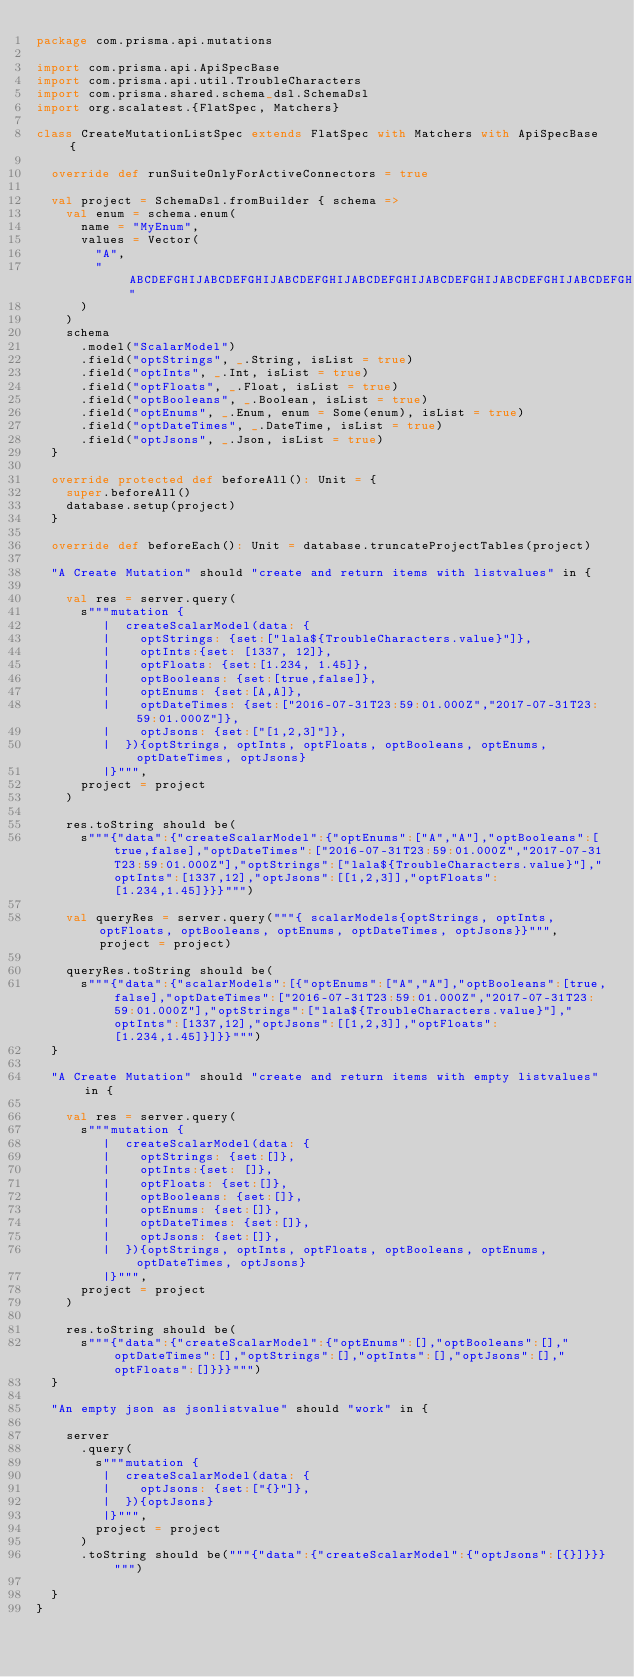Convert code to text. <code><loc_0><loc_0><loc_500><loc_500><_Scala_>package com.prisma.api.mutations

import com.prisma.api.ApiSpecBase
import com.prisma.api.util.TroubleCharacters
import com.prisma.shared.schema_dsl.SchemaDsl
import org.scalatest.{FlatSpec, Matchers}

class CreateMutationListSpec extends FlatSpec with Matchers with ApiSpecBase {

  override def runSuiteOnlyForActiveConnectors = true

  val project = SchemaDsl.fromBuilder { schema =>
    val enum = schema.enum(
      name = "MyEnum",
      values = Vector(
        "A",
        "ABCDEFGHIJABCDEFGHIJABCDEFGHIJABCDEFGHIJABCDEFGHIJABCDEFGHIJABCDEFGHIJABCDEFGHIJABCDEFGHIJABCDEFGHIJABCDEFGHIJABCDEFGHIJABCDEFGHIJABCDEFGHIJABCDEFGHIJABCDEFGHIJABCDEFGHIJABCDEFGHIJABCDEFGHIJABCDEFGHIJ"
      )
    )
    schema
      .model("ScalarModel")
      .field("optStrings", _.String, isList = true)
      .field("optInts", _.Int, isList = true)
      .field("optFloats", _.Float, isList = true)
      .field("optBooleans", _.Boolean, isList = true)
      .field("optEnums", _.Enum, enum = Some(enum), isList = true)
      .field("optDateTimes", _.DateTime, isList = true)
      .field("optJsons", _.Json, isList = true)
  }

  override protected def beforeAll(): Unit = {
    super.beforeAll()
    database.setup(project)
  }

  override def beforeEach(): Unit = database.truncateProjectTables(project)

  "A Create Mutation" should "create and return items with listvalues" in {

    val res = server.query(
      s"""mutation {
         |  createScalarModel(data: {
         |    optStrings: {set:["lala${TroubleCharacters.value}"]},
         |    optInts:{set: [1337, 12]},
         |    optFloats: {set:[1.234, 1.45]},
         |    optBooleans: {set:[true,false]},
         |    optEnums: {set:[A,A]},
         |    optDateTimes: {set:["2016-07-31T23:59:01.000Z","2017-07-31T23:59:01.000Z"]},
         |    optJsons: {set:["[1,2,3]"]},
         |  }){optStrings, optInts, optFloats, optBooleans, optEnums, optDateTimes, optJsons}
         |}""",
      project = project
    )

    res.toString should be(
      s"""{"data":{"createScalarModel":{"optEnums":["A","A"],"optBooleans":[true,false],"optDateTimes":["2016-07-31T23:59:01.000Z","2017-07-31T23:59:01.000Z"],"optStrings":["lala${TroubleCharacters.value}"],"optInts":[1337,12],"optJsons":[[1,2,3]],"optFloats":[1.234,1.45]}}}""")

    val queryRes = server.query("""{ scalarModels{optStrings, optInts, optFloats, optBooleans, optEnums, optDateTimes, optJsons}}""", project = project)

    queryRes.toString should be(
      s"""{"data":{"scalarModels":[{"optEnums":["A","A"],"optBooleans":[true,false],"optDateTimes":["2016-07-31T23:59:01.000Z","2017-07-31T23:59:01.000Z"],"optStrings":["lala${TroubleCharacters.value}"],"optInts":[1337,12],"optJsons":[[1,2,3]],"optFloats":[1.234,1.45]}]}}""")
  }

  "A Create Mutation" should "create and return items with empty listvalues" in {

    val res = server.query(
      s"""mutation {
         |  createScalarModel(data: {
         |    optStrings: {set:[]},
         |    optInts:{set: []},
         |    optFloats: {set:[]},
         |    optBooleans: {set:[]},
         |    optEnums: {set:[]},
         |    optDateTimes: {set:[]},
         |    optJsons: {set:[]},
         |  }){optStrings, optInts, optFloats, optBooleans, optEnums, optDateTimes, optJsons}
         |}""",
      project = project
    )

    res.toString should be(
      s"""{"data":{"createScalarModel":{"optEnums":[],"optBooleans":[],"optDateTimes":[],"optStrings":[],"optInts":[],"optJsons":[],"optFloats":[]}}}""")
  }

  "An empty json as jsonlistvalue" should "work" in {

    server
      .query(
        s"""mutation {
         |  createScalarModel(data: {
         |    optJsons: {set:["{}"]},
         |  }){optJsons}
         |}""",
        project = project
      )
      .toString should be("""{"data":{"createScalarModel":{"optJsons":[{}]}}}""")

  }
}
</code> 